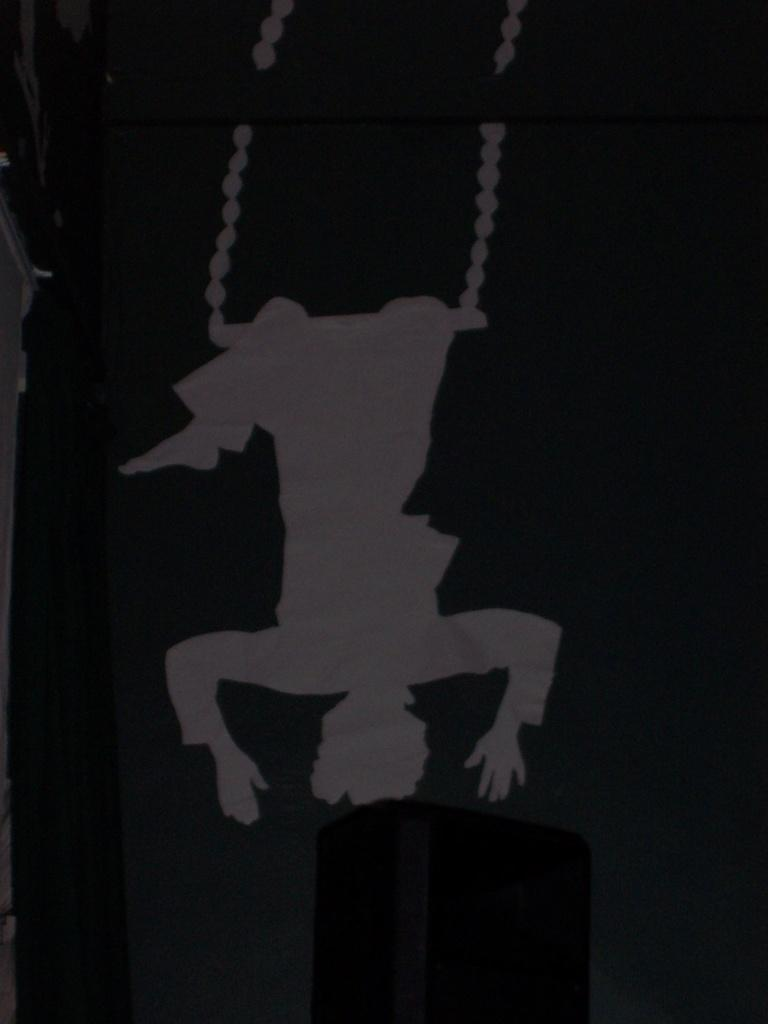What type of design is featured on the wall in the image? There is a wallpaper in the image. What is happening on the wallpaper? A person is hanging on a rope on the wallpaper. What can be seen in the background of the image? There is a building visible in the image. What type of watch is the person wearing on the wallpaper? There is no watch visible on the person in the wallpaper. What material is used to cover the building in the image? The image does not provide information about the material used to cover the building. 